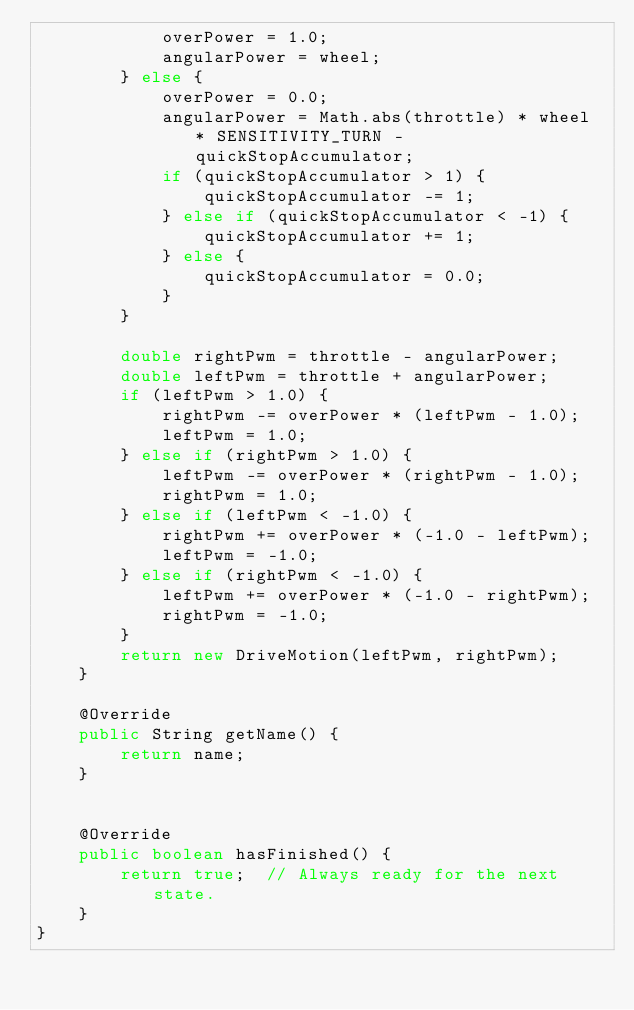Convert code to text. <code><loc_0><loc_0><loc_500><loc_500><_Java_>            overPower = 1.0;
            angularPower = wheel;
        } else {
            overPower = 0.0;
            angularPower = Math.abs(throttle) * wheel * SENSITIVITY_TURN - quickStopAccumulator;
            if (quickStopAccumulator > 1) {
                quickStopAccumulator -= 1;
            } else if (quickStopAccumulator < -1) {
                quickStopAccumulator += 1;
            } else {
                quickStopAccumulator = 0.0;
            }
        }

        double rightPwm = throttle - angularPower;
        double leftPwm = throttle + angularPower;
        if (leftPwm > 1.0) {
            rightPwm -= overPower * (leftPwm - 1.0);
            leftPwm = 1.0;
        } else if (rightPwm > 1.0) {
            leftPwm -= overPower * (rightPwm - 1.0);
            rightPwm = 1.0;
        } else if (leftPwm < -1.0) {
            rightPwm += overPower * (-1.0 - leftPwm);
            leftPwm = -1.0;
        } else if (rightPwm < -1.0) {
            leftPwm += overPower * (-1.0 - rightPwm);
            rightPwm = -1.0;
        }
		return new DriveMotion(leftPwm, rightPwm);
	}
	
	@Override
	public String getName() {
		return name;
    }
    

	@Override
	public boolean hasFinished() {
		return true;  // Always ready for the next state.
	}
}
</code> 